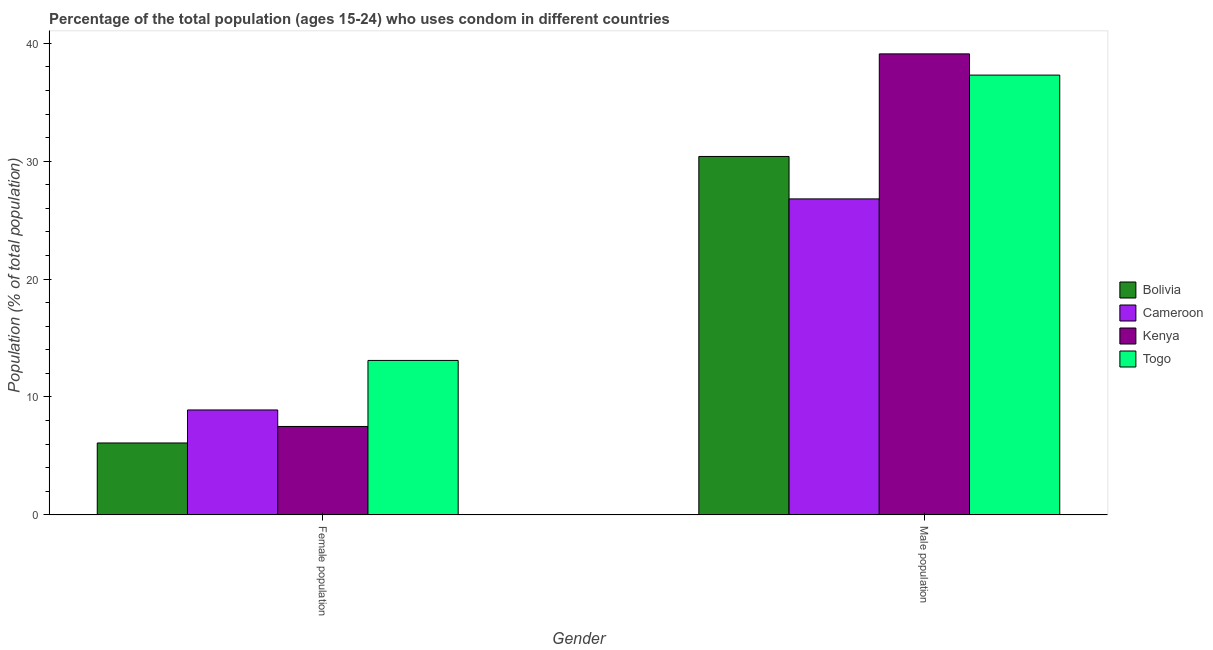How many groups of bars are there?
Offer a terse response. 2. Are the number of bars per tick equal to the number of legend labels?
Give a very brief answer. Yes. Are the number of bars on each tick of the X-axis equal?
Provide a succinct answer. Yes. How many bars are there on the 2nd tick from the left?
Your answer should be compact. 4. What is the label of the 1st group of bars from the left?
Ensure brevity in your answer.  Female population. Across all countries, what is the maximum male population?
Your response must be concise. 39.1. In which country was the male population maximum?
Offer a terse response. Kenya. In which country was the male population minimum?
Offer a very short reply. Cameroon. What is the total female population in the graph?
Give a very brief answer. 35.6. What is the difference between the female population in Cameroon and that in Bolivia?
Make the answer very short. 2.8. What is the difference between the female population in Cameroon and the male population in Togo?
Make the answer very short. -28.4. What is the average male population per country?
Give a very brief answer. 33.4. What is the difference between the male population and female population in Bolivia?
Keep it short and to the point. 24.3. In how many countries, is the male population greater than 20 %?
Your answer should be very brief. 4. What is the ratio of the male population in Cameroon to that in Togo?
Your answer should be compact. 0.72. Is the male population in Cameroon less than that in Togo?
Offer a terse response. Yes. In how many countries, is the male population greater than the average male population taken over all countries?
Your answer should be compact. 2. What does the 3rd bar from the left in Male population represents?
Provide a short and direct response. Kenya. What does the 2nd bar from the right in Male population represents?
Offer a terse response. Kenya. How many bars are there?
Give a very brief answer. 8. What is the difference between two consecutive major ticks on the Y-axis?
Give a very brief answer. 10. Are the values on the major ticks of Y-axis written in scientific E-notation?
Your response must be concise. No. Does the graph contain any zero values?
Ensure brevity in your answer.  No. How many legend labels are there?
Your answer should be very brief. 4. How are the legend labels stacked?
Offer a terse response. Vertical. What is the title of the graph?
Provide a succinct answer. Percentage of the total population (ages 15-24) who uses condom in different countries. What is the label or title of the Y-axis?
Your response must be concise. Population (% of total population) . What is the Population (% of total population)  of Bolivia in Female population?
Your answer should be compact. 6.1. What is the Population (% of total population)  in Cameroon in Female population?
Make the answer very short. 8.9. What is the Population (% of total population)  of Bolivia in Male population?
Make the answer very short. 30.4. What is the Population (% of total population)  of Cameroon in Male population?
Make the answer very short. 26.8. What is the Population (% of total population)  of Kenya in Male population?
Your response must be concise. 39.1. What is the Population (% of total population)  of Togo in Male population?
Offer a very short reply. 37.3. Across all Gender, what is the maximum Population (% of total population)  of Bolivia?
Ensure brevity in your answer.  30.4. Across all Gender, what is the maximum Population (% of total population)  of Cameroon?
Offer a very short reply. 26.8. Across all Gender, what is the maximum Population (% of total population)  in Kenya?
Provide a succinct answer. 39.1. Across all Gender, what is the maximum Population (% of total population)  of Togo?
Provide a short and direct response. 37.3. Across all Gender, what is the minimum Population (% of total population)  in Bolivia?
Make the answer very short. 6.1. Across all Gender, what is the minimum Population (% of total population)  of Togo?
Ensure brevity in your answer.  13.1. What is the total Population (% of total population)  of Bolivia in the graph?
Offer a terse response. 36.5. What is the total Population (% of total population)  in Cameroon in the graph?
Provide a short and direct response. 35.7. What is the total Population (% of total population)  of Kenya in the graph?
Offer a terse response. 46.6. What is the total Population (% of total population)  in Togo in the graph?
Offer a very short reply. 50.4. What is the difference between the Population (% of total population)  of Bolivia in Female population and that in Male population?
Your answer should be very brief. -24.3. What is the difference between the Population (% of total population)  in Cameroon in Female population and that in Male population?
Your response must be concise. -17.9. What is the difference between the Population (% of total population)  in Kenya in Female population and that in Male population?
Ensure brevity in your answer.  -31.6. What is the difference between the Population (% of total population)  in Togo in Female population and that in Male population?
Your answer should be very brief. -24.2. What is the difference between the Population (% of total population)  in Bolivia in Female population and the Population (% of total population)  in Cameroon in Male population?
Your answer should be very brief. -20.7. What is the difference between the Population (% of total population)  of Bolivia in Female population and the Population (% of total population)  of Kenya in Male population?
Offer a terse response. -33. What is the difference between the Population (% of total population)  of Bolivia in Female population and the Population (% of total population)  of Togo in Male population?
Your answer should be very brief. -31.2. What is the difference between the Population (% of total population)  of Cameroon in Female population and the Population (% of total population)  of Kenya in Male population?
Provide a succinct answer. -30.2. What is the difference between the Population (% of total population)  in Cameroon in Female population and the Population (% of total population)  in Togo in Male population?
Make the answer very short. -28.4. What is the difference between the Population (% of total population)  in Kenya in Female population and the Population (% of total population)  in Togo in Male population?
Provide a short and direct response. -29.8. What is the average Population (% of total population)  of Bolivia per Gender?
Make the answer very short. 18.25. What is the average Population (% of total population)  of Cameroon per Gender?
Keep it short and to the point. 17.85. What is the average Population (% of total population)  in Kenya per Gender?
Your answer should be compact. 23.3. What is the average Population (% of total population)  of Togo per Gender?
Your response must be concise. 25.2. What is the difference between the Population (% of total population)  in Bolivia and Population (% of total population)  in Kenya in Female population?
Ensure brevity in your answer.  -1.4. What is the difference between the Population (% of total population)  in Bolivia and Population (% of total population)  in Togo in Female population?
Your answer should be compact. -7. What is the difference between the Population (% of total population)  in Cameroon and Population (% of total population)  in Kenya in Female population?
Provide a succinct answer. 1.4. What is the difference between the Population (% of total population)  in Kenya and Population (% of total population)  in Togo in Female population?
Make the answer very short. -5.6. What is the difference between the Population (% of total population)  of Bolivia and Population (% of total population)  of Togo in Male population?
Your answer should be compact. -6.9. What is the difference between the Population (% of total population)  in Cameroon and Population (% of total population)  in Togo in Male population?
Your response must be concise. -10.5. What is the difference between the Population (% of total population)  in Kenya and Population (% of total population)  in Togo in Male population?
Provide a short and direct response. 1.8. What is the ratio of the Population (% of total population)  of Bolivia in Female population to that in Male population?
Offer a very short reply. 0.2. What is the ratio of the Population (% of total population)  in Cameroon in Female population to that in Male population?
Ensure brevity in your answer.  0.33. What is the ratio of the Population (% of total population)  in Kenya in Female population to that in Male population?
Ensure brevity in your answer.  0.19. What is the ratio of the Population (% of total population)  of Togo in Female population to that in Male population?
Provide a succinct answer. 0.35. What is the difference between the highest and the second highest Population (% of total population)  in Bolivia?
Give a very brief answer. 24.3. What is the difference between the highest and the second highest Population (% of total population)  of Cameroon?
Offer a terse response. 17.9. What is the difference between the highest and the second highest Population (% of total population)  in Kenya?
Your answer should be compact. 31.6. What is the difference between the highest and the second highest Population (% of total population)  in Togo?
Your answer should be compact. 24.2. What is the difference between the highest and the lowest Population (% of total population)  of Bolivia?
Offer a terse response. 24.3. What is the difference between the highest and the lowest Population (% of total population)  in Cameroon?
Provide a short and direct response. 17.9. What is the difference between the highest and the lowest Population (% of total population)  in Kenya?
Your answer should be compact. 31.6. What is the difference between the highest and the lowest Population (% of total population)  in Togo?
Your response must be concise. 24.2. 